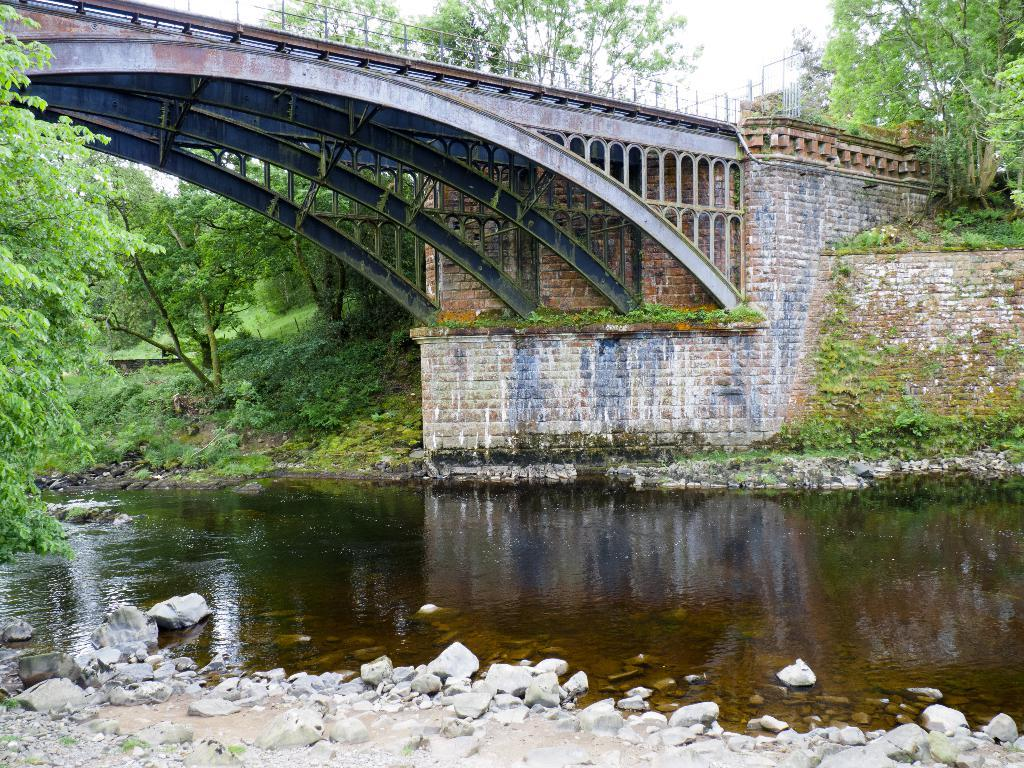What is present in the image that represents a natural element? There is water in the image. What can be found in the water in the image? There are stones in the image. What type of vegetation is present in the image? There are plants and trees in the image. What type of structure is present in the image? There is a wall and a bridge in the image. What is visible in the background of the image? The sky is visible in the background of the image. Can you describe the girl's outfit in the image? There is no girl present in the image. What type of laborer can be seen working on the bridge in the image? There are no laborers present in the image, and the bridge is not being worked on. 